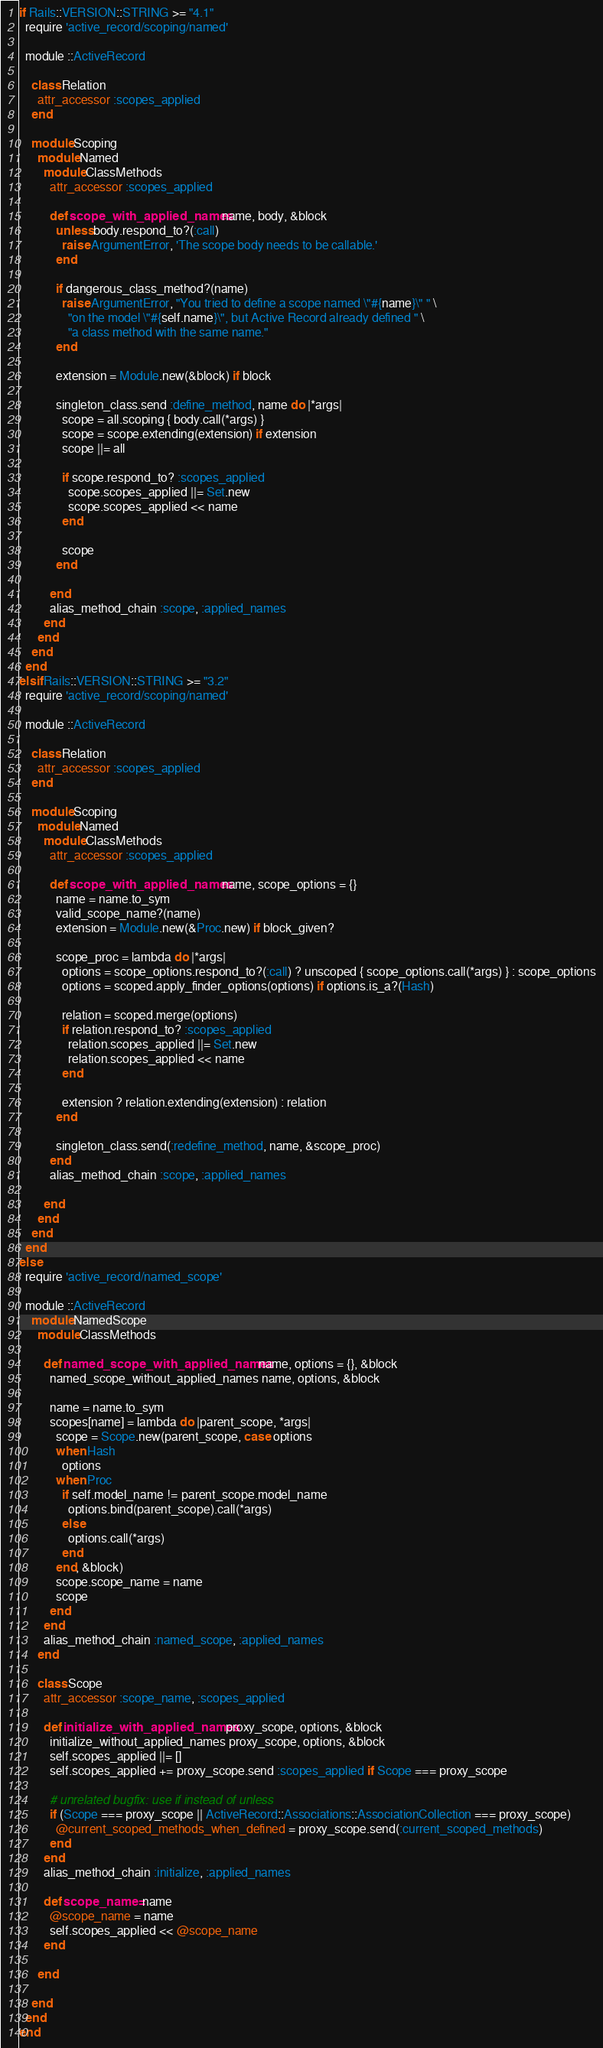Convert code to text. <code><loc_0><loc_0><loc_500><loc_500><_Ruby_>
if Rails::VERSION::STRING >= "4.1"
  require 'active_record/scoping/named'

  module ::ActiveRecord

    class Relation
      attr_accessor :scopes_applied
    end

    module Scoping
      module Named
        module ClassMethods
          attr_accessor :scopes_applied

          def scope_with_applied_names name, body, &block
            unless body.respond_to?(:call)
              raise ArgumentError, 'The scope body needs to be callable.'
            end

            if dangerous_class_method?(name)
              raise ArgumentError, "You tried to define a scope named \"#{name}\" " \
                "on the model \"#{self.name}\", but Active Record already defined " \
                "a class method with the same name."
            end

            extension = Module.new(&block) if block

            singleton_class.send :define_method, name do |*args|
              scope = all.scoping { body.call(*args) }
              scope = scope.extending(extension) if extension
              scope ||= all

              if scope.respond_to? :scopes_applied
                scope.scopes_applied ||= Set.new
                scope.scopes_applied << name
              end

              scope
            end

          end
          alias_method_chain :scope, :applied_names
        end
      end
    end
  end
elsif Rails::VERSION::STRING >= "3.2"
  require 'active_record/scoping/named'

  module ::ActiveRecord

    class Relation
      attr_accessor :scopes_applied
    end

    module Scoping
      module Named
        module ClassMethods
          attr_accessor :scopes_applied

          def scope_with_applied_names name, scope_options = {}
            name = name.to_sym
            valid_scope_name?(name)
            extension = Module.new(&Proc.new) if block_given?

            scope_proc = lambda do |*args|
              options = scope_options.respond_to?(:call) ? unscoped { scope_options.call(*args) } : scope_options
              options = scoped.apply_finder_options(options) if options.is_a?(Hash)

              relation = scoped.merge(options)
              if relation.respond_to? :scopes_applied
                relation.scopes_applied ||= Set.new
                relation.scopes_applied << name
              end

              extension ? relation.extending(extension) : relation
            end

            singleton_class.send(:redefine_method, name, &scope_proc)
          end
          alias_method_chain :scope, :applied_names

        end
      end
    end
  end
else
  require 'active_record/named_scope'

  module ::ActiveRecord
    module NamedScope
      module ClassMethods

        def named_scope_with_applied_names name, options = {}, &block
          named_scope_without_applied_names name, options, &block

          name = name.to_sym
          scopes[name] = lambda do |parent_scope, *args|
            scope = Scope.new(parent_scope, case options
            when Hash
              options
            when Proc
              if self.model_name != parent_scope.model_name
                options.bind(parent_scope).call(*args)
              else
                options.call(*args)
              end
            end, &block)
            scope.scope_name = name
            scope
          end
        end
        alias_method_chain :named_scope, :applied_names
      end

      class Scope
        attr_accessor :scope_name, :scopes_applied

        def initialize_with_applied_names proxy_scope, options, &block
          initialize_without_applied_names proxy_scope, options, &block
          self.scopes_applied ||= []
          self.scopes_applied += proxy_scope.send :scopes_applied if Scope === proxy_scope

          # unrelated bugfix: use if instead of unless
          if (Scope === proxy_scope || ActiveRecord::Associations::AssociationCollection === proxy_scope)
            @current_scoped_methods_when_defined = proxy_scope.send(:current_scoped_methods)
          end
        end
        alias_method_chain :initialize, :applied_names

        def scope_name= name
          @scope_name = name
          self.scopes_applied << @scope_name
        end

      end

    end
  end
end
</code> 